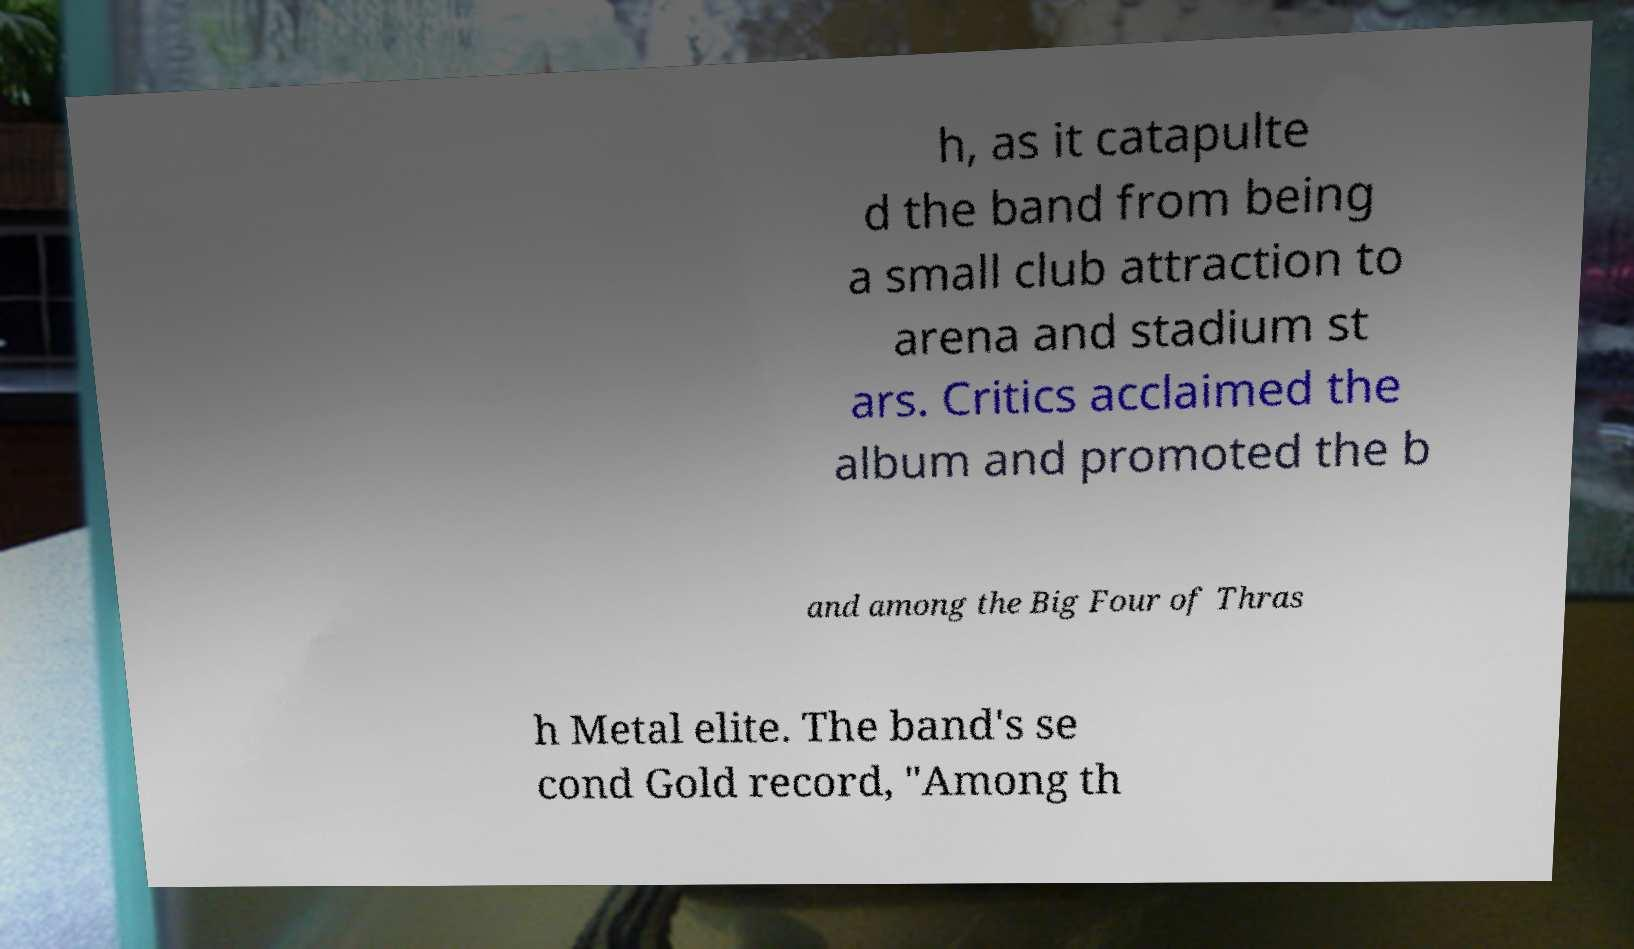Can you read and provide the text displayed in the image?This photo seems to have some interesting text. Can you extract and type it out for me? h, as it catapulte d the band from being a small club attraction to arena and stadium st ars. Critics acclaimed the album and promoted the b and among the Big Four of Thras h Metal elite. The band's se cond Gold record, "Among th 